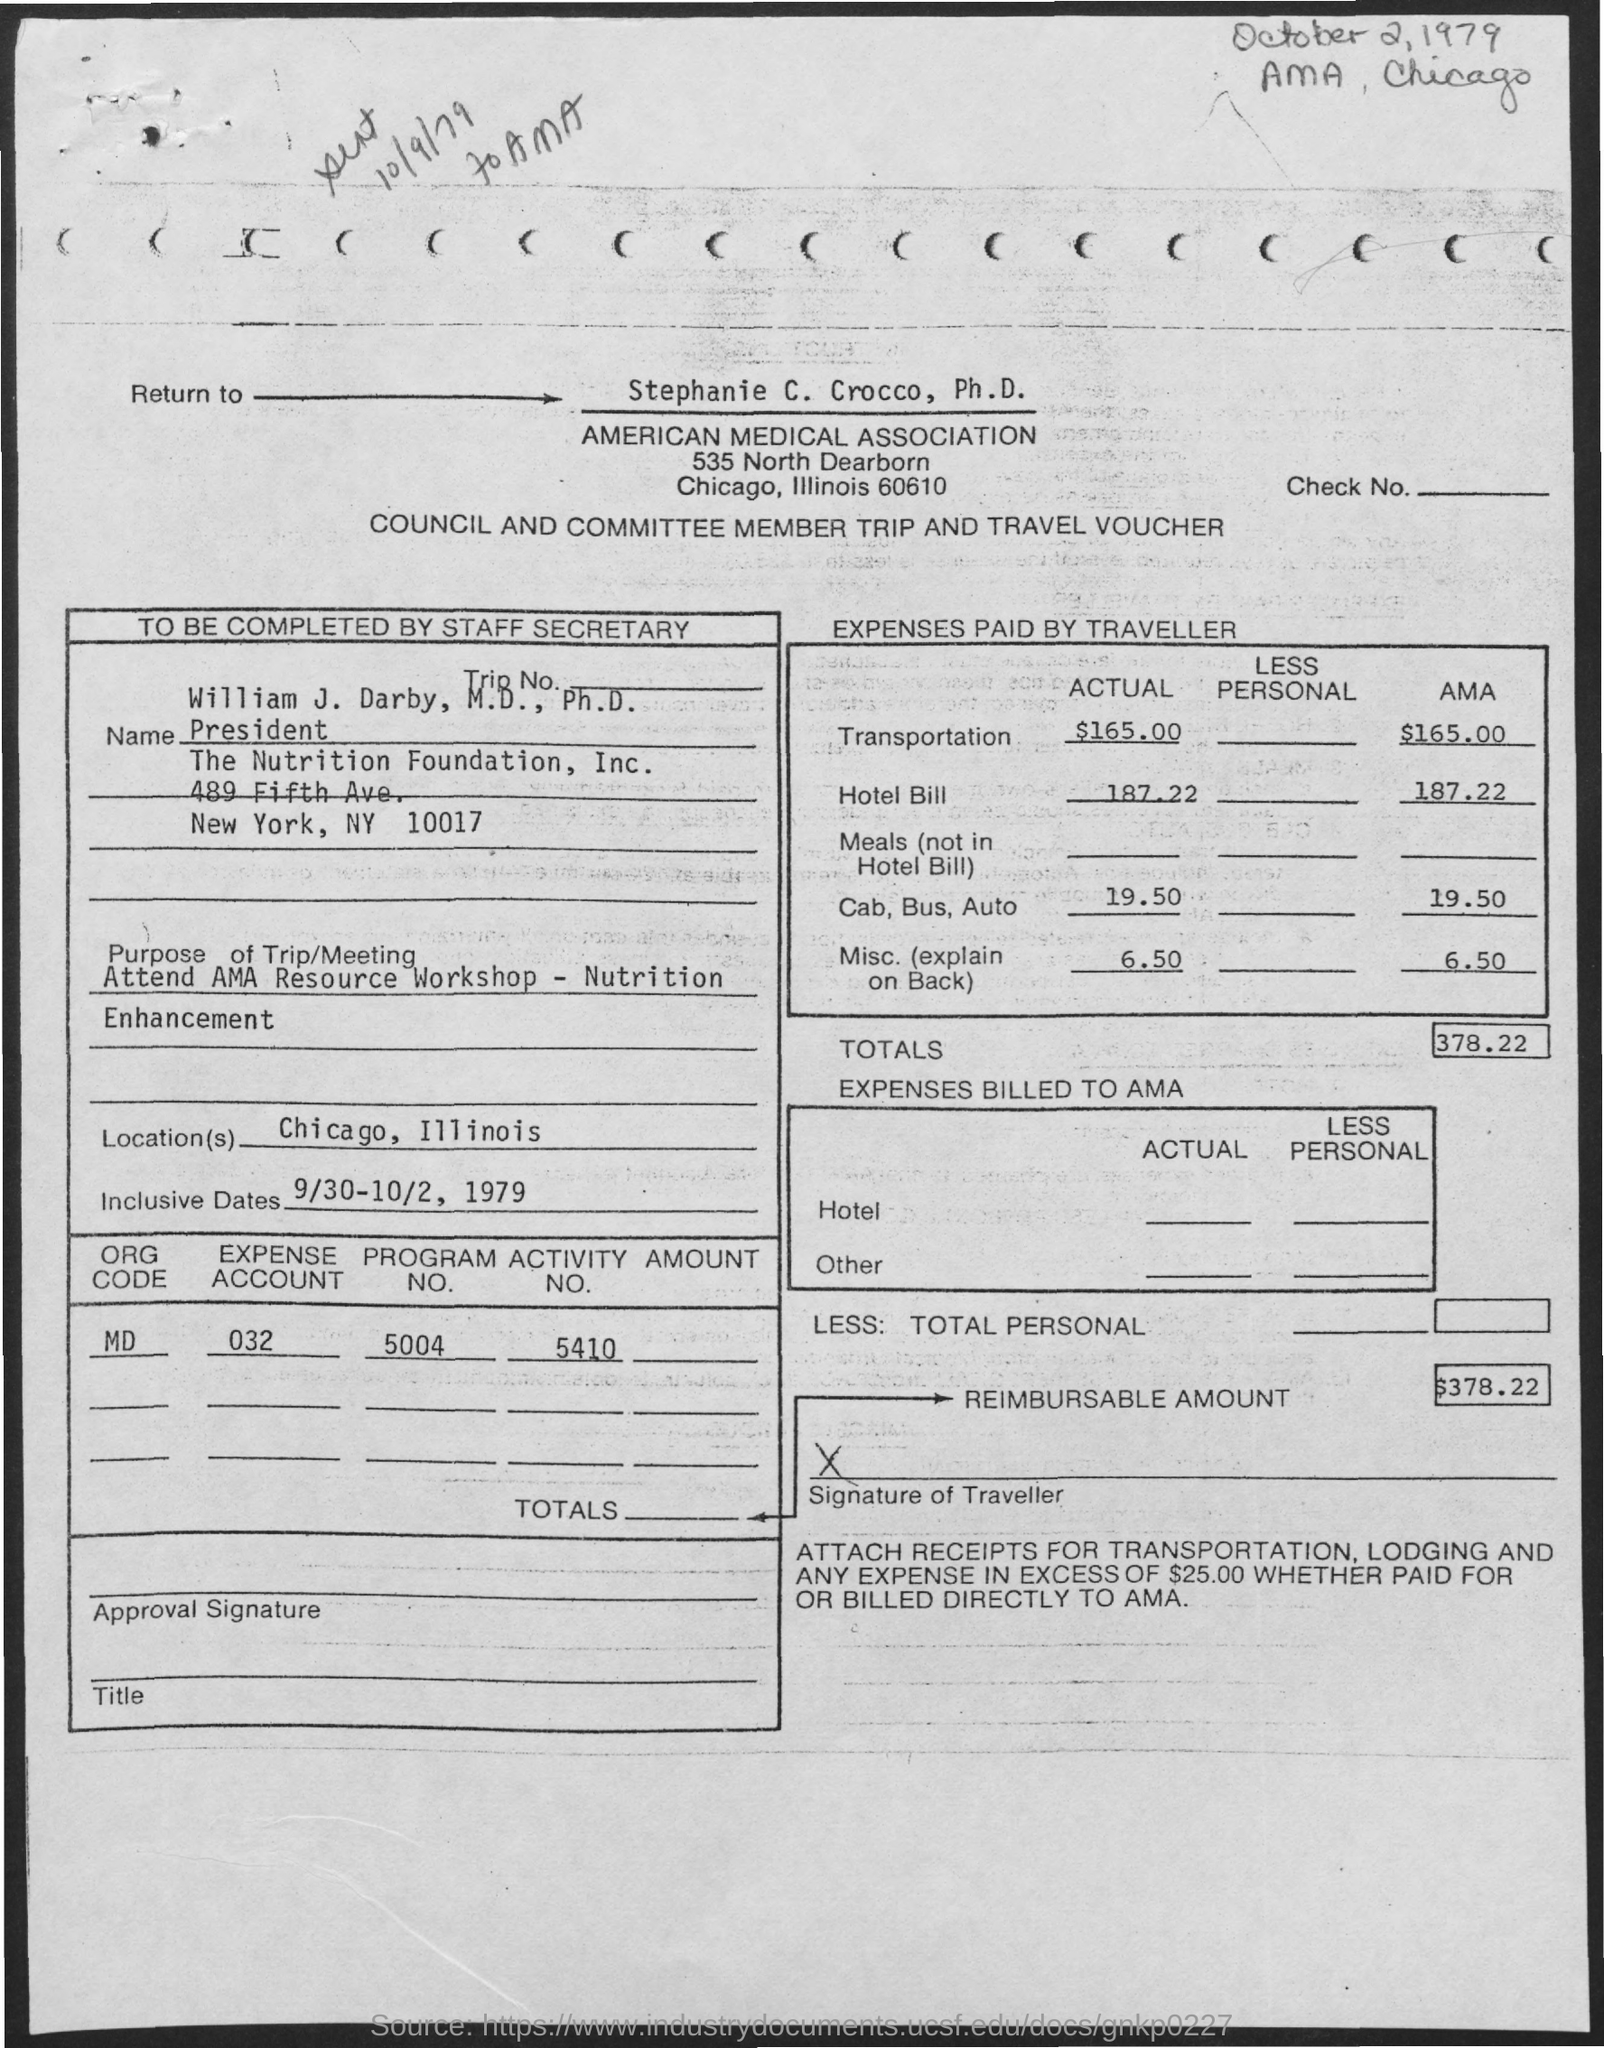Point out several critical features in this image. The actual hotel expenses paid by the traveler were $187.22. The total expenses billed to the American Medical Association (AMA) is 378.22 dollars. The reimbursable amount mentioned in the provided form is $378.22. William J. Darby holds the designation of president. The actual cost of cab, bus, or auto expenses paid by the traveler is $19.50. 